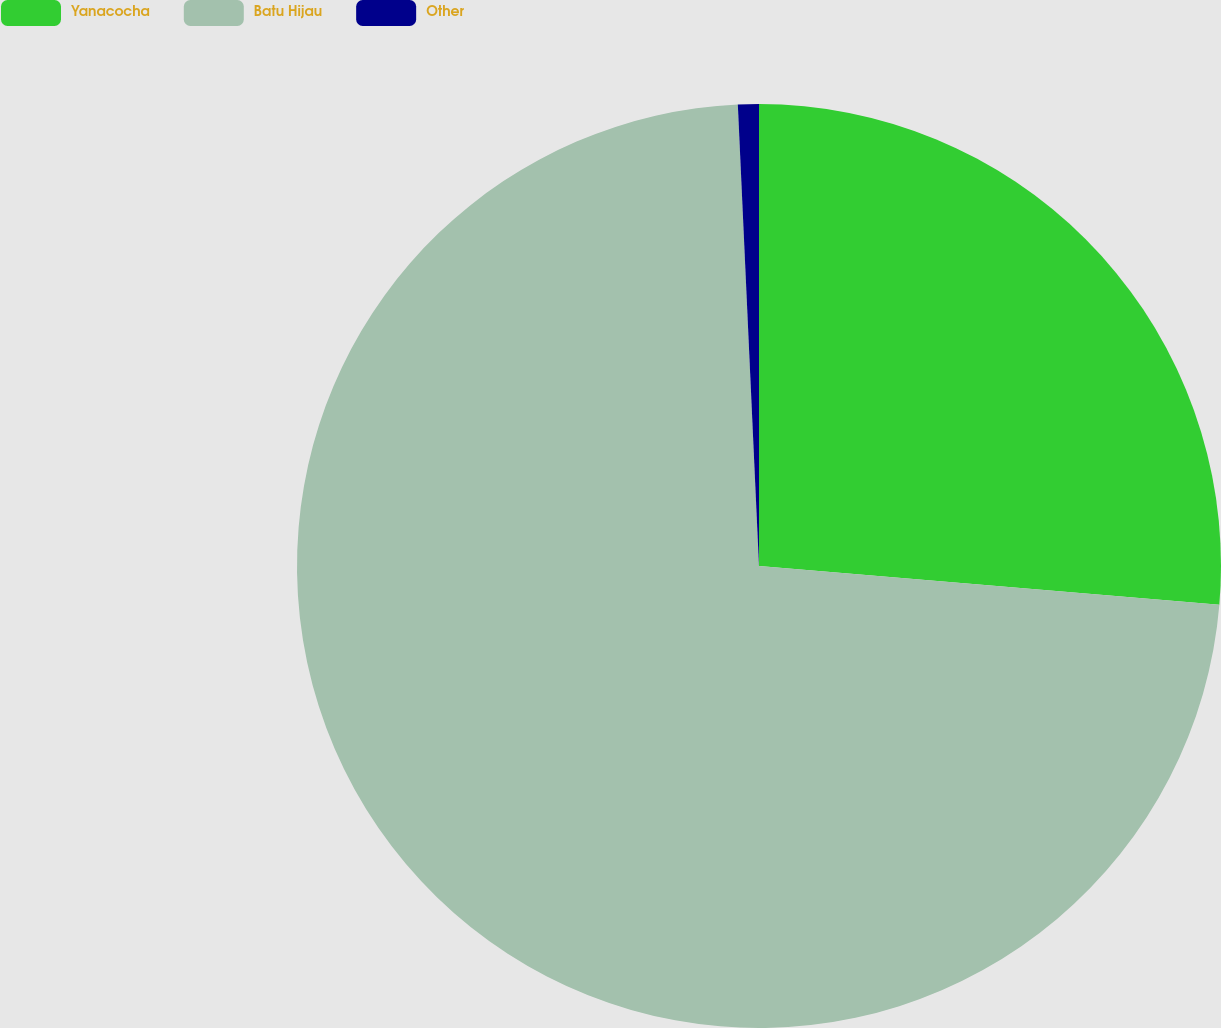<chart> <loc_0><loc_0><loc_500><loc_500><pie_chart><fcel>Yanacocha<fcel>Batu Hijau<fcel>Other<nl><fcel>26.34%<fcel>72.93%<fcel>0.73%<nl></chart> 